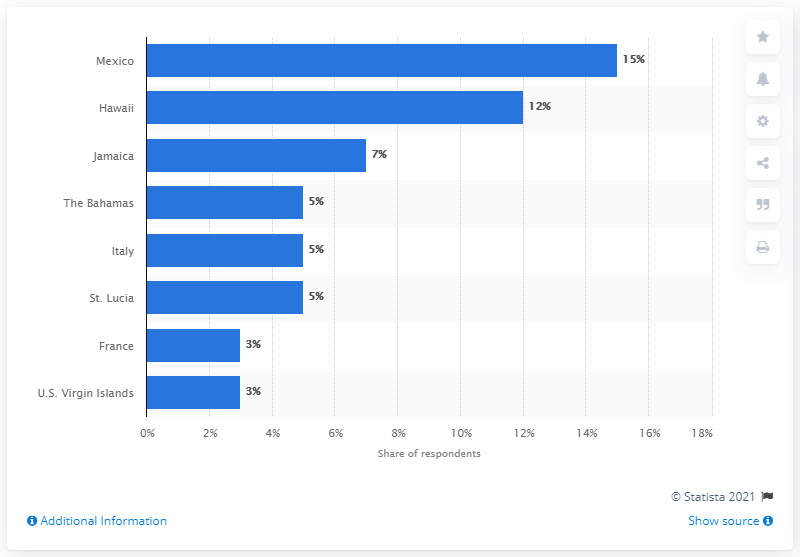Are there new emerging honeymoon destinations that aren't as well known? Yes, there are lesser-known but up-and-coming honeymoon spots such as Belize for its beautiful beaches and Mayan ruins, or Portugal for its historic charm, coastal towns, and delicious cuisine. 